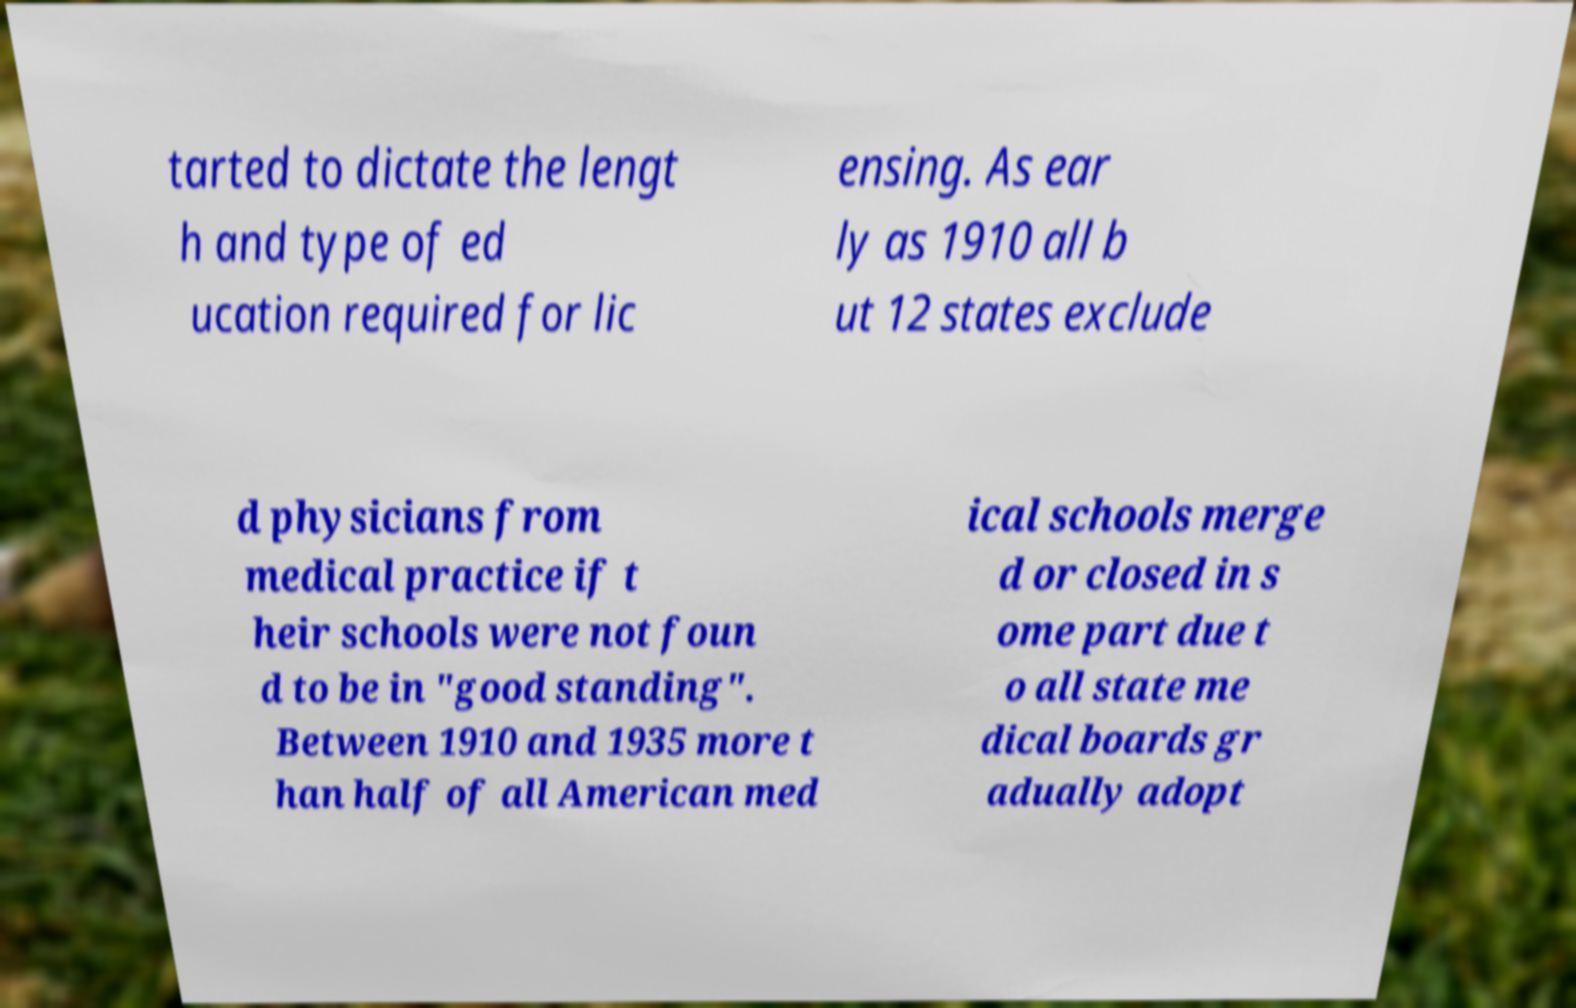Can you read and provide the text displayed in the image?This photo seems to have some interesting text. Can you extract and type it out for me? tarted to dictate the lengt h and type of ed ucation required for lic ensing. As ear ly as 1910 all b ut 12 states exclude d physicians from medical practice if t heir schools were not foun d to be in "good standing". Between 1910 and 1935 more t han half of all American med ical schools merge d or closed in s ome part due t o all state me dical boards gr adually adopt 